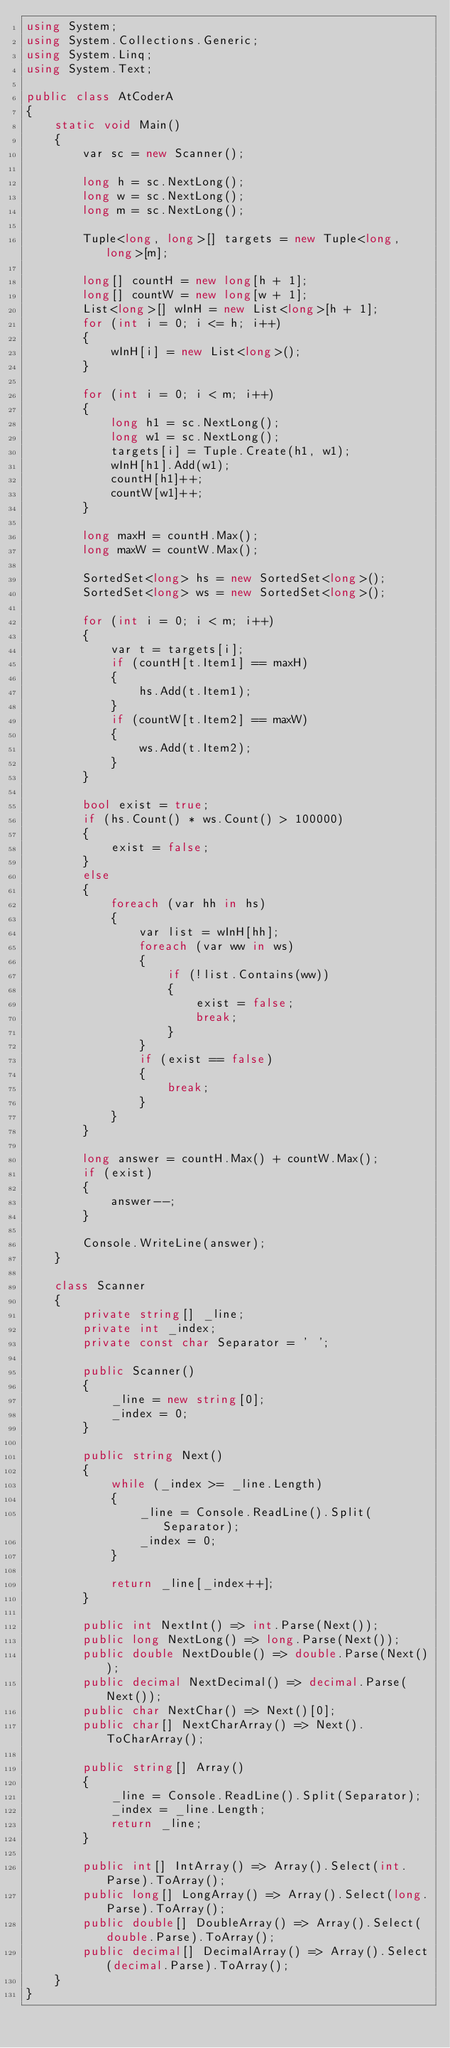Convert code to text. <code><loc_0><loc_0><loc_500><loc_500><_C#_>using System;
using System.Collections.Generic;
using System.Linq;
using System.Text;

public class AtCoderA
{
    static void Main()
    {
        var sc = new Scanner();

        long h = sc.NextLong();
        long w = sc.NextLong();
        long m = sc.NextLong();

        Tuple<long, long>[] targets = new Tuple<long, long>[m];

        long[] countH = new long[h + 1];
        long[] countW = new long[w + 1];
        List<long>[] wInH = new List<long>[h + 1];
        for (int i = 0; i <= h; i++)
        {
            wInH[i] = new List<long>();
        }

        for (int i = 0; i < m; i++)
        {
            long h1 = sc.NextLong();
            long w1 = sc.NextLong();
            targets[i] = Tuple.Create(h1, w1);
            wInH[h1].Add(w1);
            countH[h1]++;
            countW[w1]++;
        }

        long maxH = countH.Max();
        long maxW = countW.Max();

        SortedSet<long> hs = new SortedSet<long>();
        SortedSet<long> ws = new SortedSet<long>();

        for (int i = 0; i < m; i++)
        {
            var t = targets[i];
            if (countH[t.Item1] == maxH)
            {
                hs.Add(t.Item1);
            }
            if (countW[t.Item2] == maxW)
            {
                ws.Add(t.Item2);
            }
        }

        bool exist = true;
        if (hs.Count() * ws.Count() > 100000)
        {
            exist = false;
        }
        else
        {
            foreach (var hh in hs)
            {
                var list = wInH[hh];
                foreach (var ww in ws)
                {
                    if (!list.Contains(ww))
                    {
                        exist = false;
                        break;
                    }
                }
                if (exist == false)
                {
                    break;
                }
            }
        }

        long answer = countH.Max() + countW.Max();
        if (exist)
        {
            answer--;
        }

        Console.WriteLine(answer);
    }

    class Scanner
    {
        private string[] _line;
        private int _index;
        private const char Separator = ' ';

        public Scanner()
        {
            _line = new string[0];
            _index = 0;
        }

        public string Next()
        {
            while (_index >= _line.Length)
            {
                _line = Console.ReadLine().Split(Separator);
                _index = 0;
            }

            return _line[_index++];
        }

        public int NextInt() => int.Parse(Next());
        public long NextLong() => long.Parse(Next());
        public double NextDouble() => double.Parse(Next());
        public decimal NextDecimal() => decimal.Parse(Next());
        public char NextChar() => Next()[0];
        public char[] NextCharArray() => Next().ToCharArray();

        public string[] Array()
        {
            _line = Console.ReadLine().Split(Separator);
            _index = _line.Length;
            return _line;
        }

        public int[] IntArray() => Array().Select(int.Parse).ToArray();
        public long[] LongArray() => Array().Select(long.Parse).ToArray();
        public double[] DoubleArray() => Array().Select(double.Parse).ToArray();
        public decimal[] DecimalArray() => Array().Select(decimal.Parse).ToArray();
    }
}
</code> 